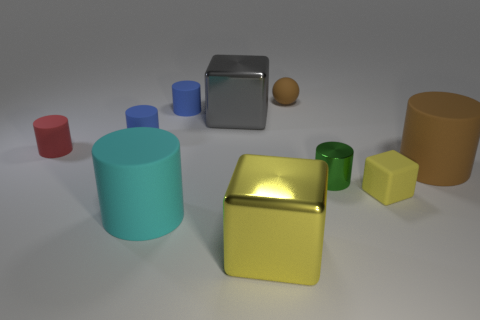Which objects in this image have a similar color? The golden yellow cube and the yellow-green cylinder share similar hues, both having a yellowish tone. The bright colors of these objects make them stand out amongst the others in the image. 